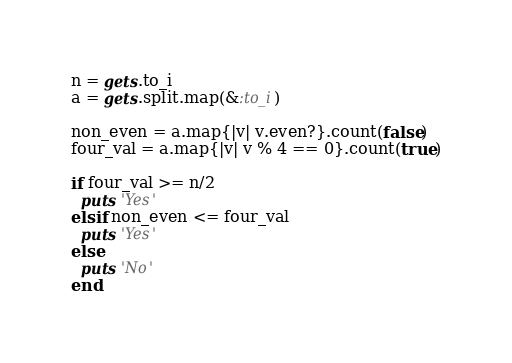Convert code to text. <code><loc_0><loc_0><loc_500><loc_500><_Ruby_>n = gets.to_i
a = gets.split.map(&:to_i)

non_even = a.map{|v| v.even?}.count(false)
four_val = a.map{|v| v % 4 == 0}.count(true)

if four_val >= n/2
  puts 'Yes'
elsif non_even <= four_val
  puts 'Yes'
else
  puts 'No'
end

</code> 